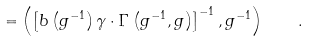<formula> <loc_0><loc_0><loc_500><loc_500>= \left ( \left [ b \left ( g ^ { - 1 } \right ) \gamma \cdot \Gamma \left ( g ^ { - 1 } , g \right ) \right ] ^ { - 1 } , g ^ { - 1 } \right ) \quad .</formula> 